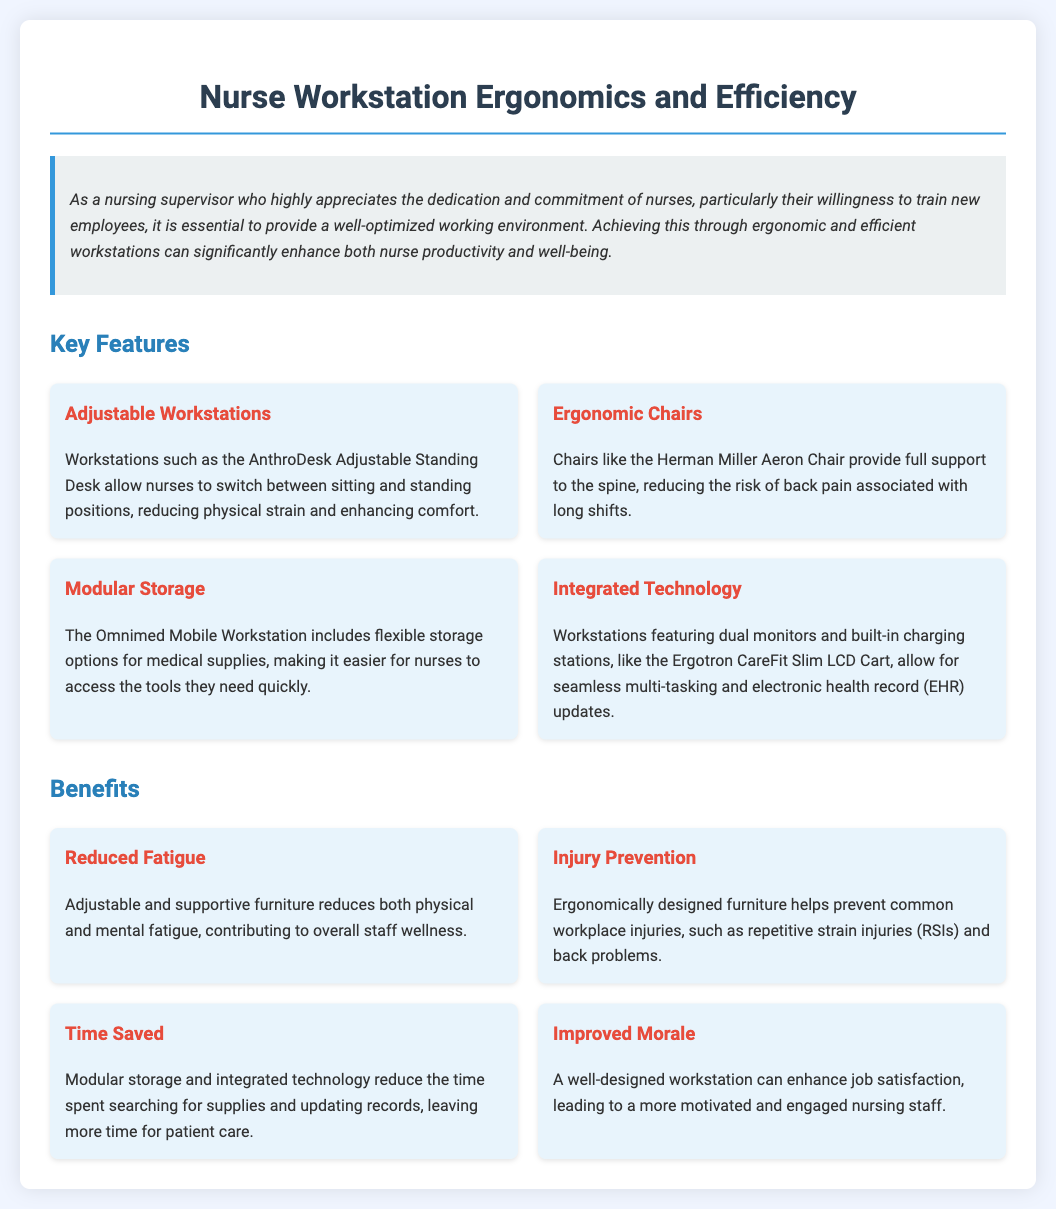what is the title of the document? The title is prominently displayed at the top of the document.
Answer: Nurse Workstation Ergonomics and Efficiency how many key features are listed? The document lists the number of key features in a specific section.
Answer: Four what ergonomic chair is mentioned? The document specifies the name of a chair designed for ergonomic support.
Answer: Herman Miller Aeron Chair what is the main benefit of adjustable furniture? The benefits section explains the effects of adjustable furniture in succinct terms.
Answer: Reduced Fatigue which feature helps with electronic health record updates? The document identifies a feature specifically designed for EHR updates.
Answer: Integrated Technology what is the purpose of modular storage? A description in the document clarifies the purpose of modular storage in workstations.
Answer: Flexibility for accessing medical supplies how does a well-designed workstation affect staff morale? The document provides a clear statement on the relationship between workstation design and morale.
Answer: Improved Morale what does "RSI" stand for in the context of preventing injuries? The acronym for common workplace injuries is defined in the benefits section.
Answer: Repetitive Strain Injuries which feature allows switching between sitting and standing? A specific workstation feature is mentioned as enabling this function.
Answer: Adjustable Workstations 